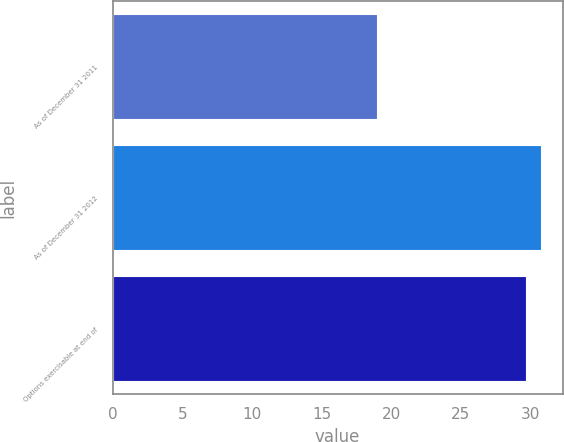Convert chart to OTSL. <chart><loc_0><loc_0><loc_500><loc_500><bar_chart><fcel>As of December 31 2011<fcel>As of December 31 2012<fcel>Options exercisable at end of<nl><fcel>18.94<fcel>30.76<fcel>29.66<nl></chart> 